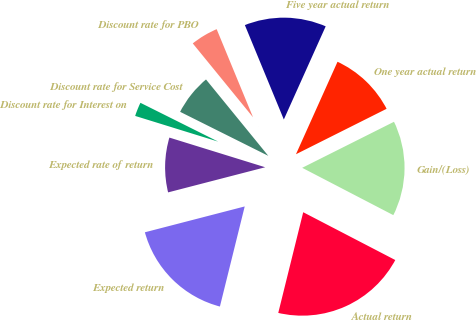Convert chart to OTSL. <chart><loc_0><loc_0><loc_500><loc_500><pie_chart><fcel>Discount rate for PBO<fcel>Discount rate for Service Cost<fcel>Discount rate for Interest on<fcel>Expected rate of return<fcel>Expected return<fcel>Actual return<fcel>Gain/(Loss)<fcel>One year actual return<fcel>Five year actual return<nl><fcel>4.66%<fcel>6.74%<fcel>2.59%<fcel>8.81%<fcel>17.1%<fcel>21.24%<fcel>15.02%<fcel>10.88%<fcel>12.95%<nl></chart> 